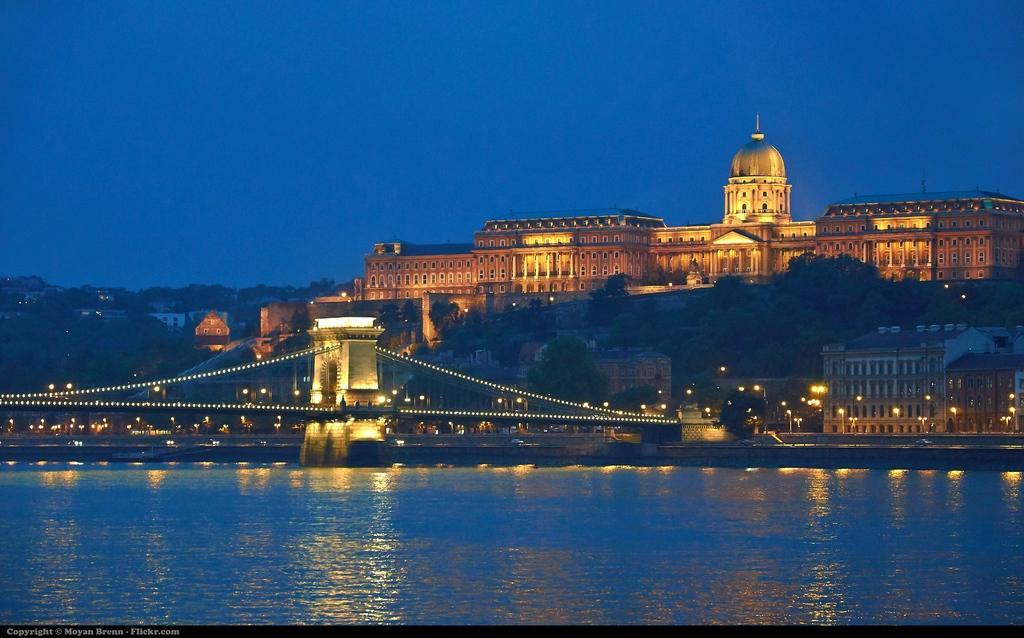Please provide a concise description of this image. To the bottom of the image there is water. Above the water there is a bridge with lights. And in the background there are trees, buildings with lights. There is a place with lights, pillars, walls and windows. And also there are many streetlight poles. To the top of the image there is a sky. 